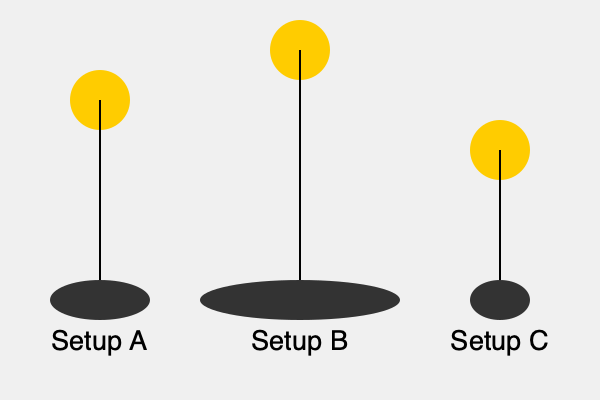In a film noir scene, you want to create dramatic shadows for your protagonist. Which lighting setup would produce the longest shadow, enhancing the mysterious atmosphere? To determine which lighting setup produces the longest shadow, we need to analyze the relationship between the light source position and the resulting shadow length. Let's break it down step-by-step:

1. Setup A: The light source is positioned at a medium height. This creates a moderate shadow length, as seen in the ellipse below the figure.

2. Setup B: The light source is positioned at the highest point among the three setups. This creates the longest shadow, as illustrated by the elongated ellipse below the figure. The higher the light source, the longer the shadow it casts.

3. Setup C: The light source is positioned at the lowest height. This creates the shortest shadow, as shown by the small ellipse below the figure.

The length of the shadow is directly related to the angle between the light source and the subject. The formula for shadow length is:

$$ \text{Shadow Length} = \frac{\text{Object Height} \times \text{Light Source Height}}{\text{Light Source Height} - \text{Object Height}} $$

As the light source height increases, the denominator of this fraction decreases, resulting in a longer shadow.

In the context of film noir, longer shadows create a more dramatic and mysterious atmosphere. They can make characters appear more imposing or create a sense of unease and tension in the scene.

Therefore, Setup B, with its high light position and resulting long shadow, would be the most effective for creating the desired film noir effect.
Answer: Setup B 